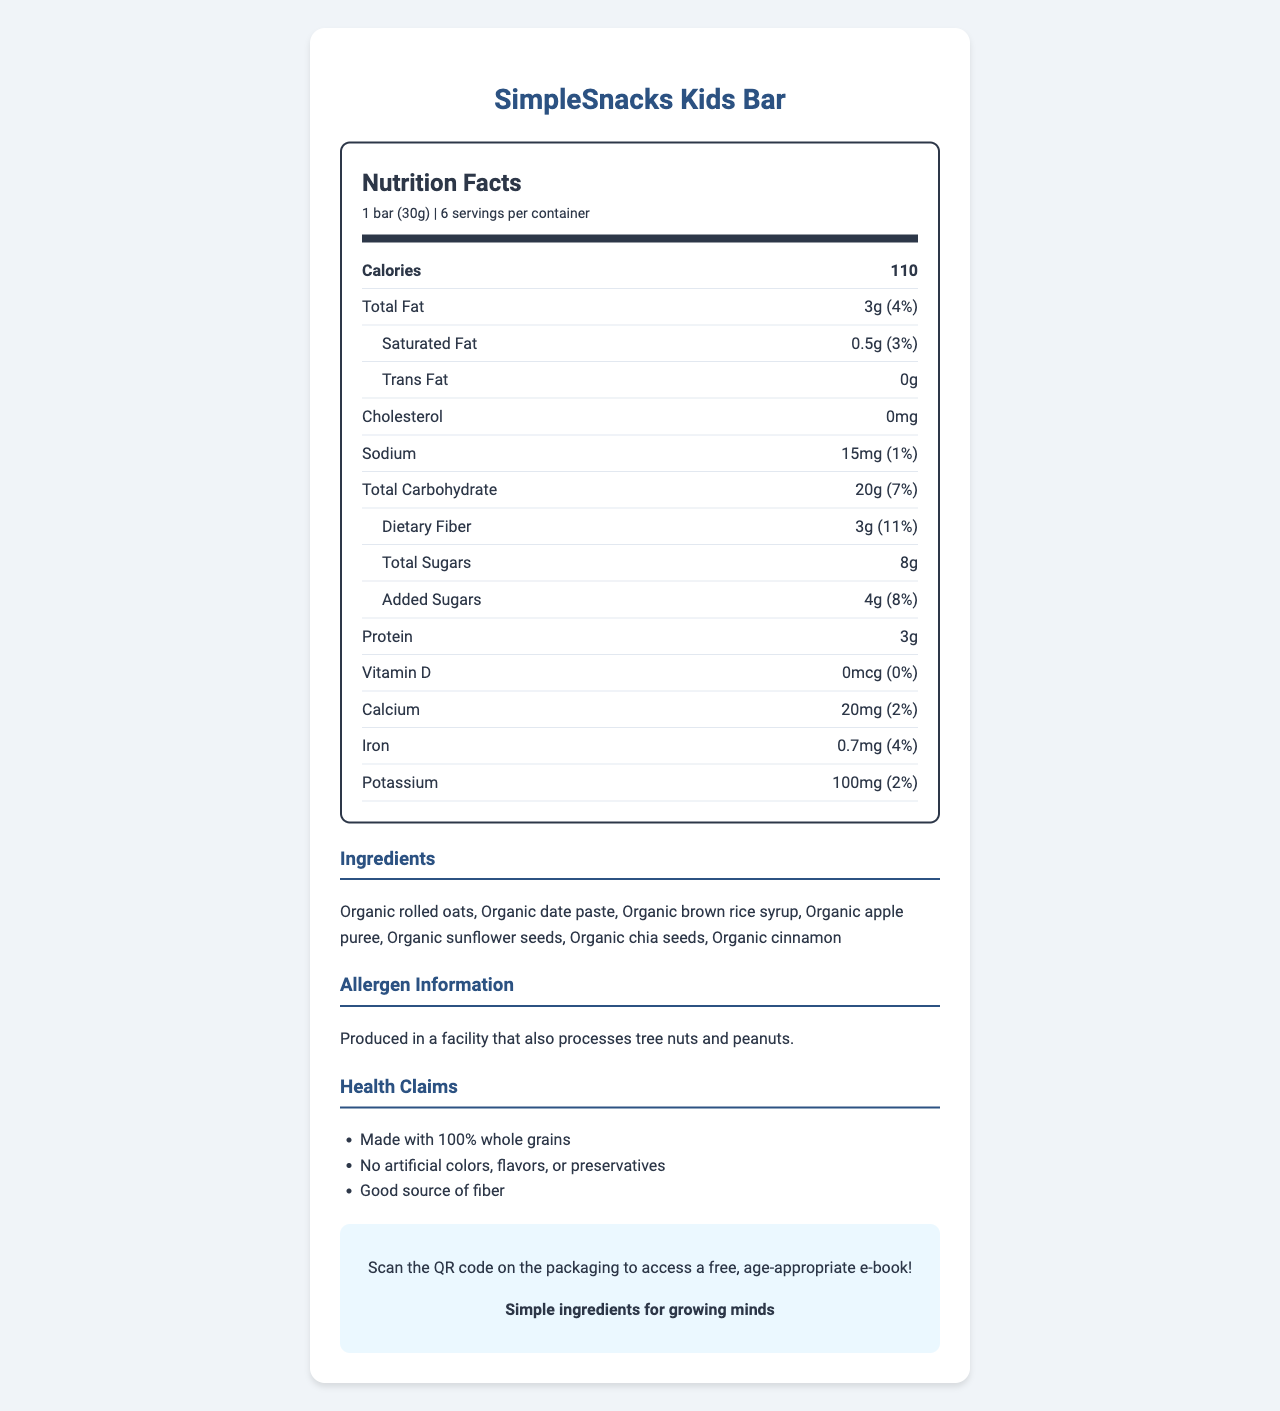what is the serving size of the SimpleSnacks Kids Bar? The serving size information is clearly indicated at the top of the Nutrition Facts section.
Answer: 1 bar (30g) how many calories are there per serving? The calories per serving are listed directly under the serving size and servings per container.
Answer: 110 calories what is the total fat content of a single bar? The total fat content is mentioned in the Nutrition Facts section under the calories.
Answer: 3g how much dietary fiber does a single bar contain? Dietary fiber content is listed in the Nutrition Facts section under the total carbohydrate information.
Answer: 3g what ingredients are used in the SimpleSnacks Kids Bar? The ingredients are listed in the Ingredients section of the document.
Answer: Organic rolled oats, Organic date paste, Organic brown rice syrup, Organic apple puree, Organic sunflower seeds, Organic chia seeds, Organic cinnamon how much protein is there per serving? The protein content is listed in the Nutrition Facts section under the added sugars.
Answer: 3g why might parents find this snack bar a good choice for children? The Health Claims section lists the benefits that might appeal to parents.
Answer: Made with 100% whole grains, No artificial colors, flavors, or preservatives, Good source of fiber what percentage of your daily value of calcium is provided by a single bar? The calcium daily value percentage is mentioned in the Nutrition Facts section near the bottom.
Answer: 2% what is the sodium content per serving? A. 5mg B. 10mg C. 15mg D. 20mg The sodium content is listed in the Nutrition Facts section.
Answer: C. 15mg which of the following is true about the SimpleSnacks Kids Bar? I. Contains artificial preservatives II. Made with 100% whole grains III. Contains tree nuts The Health Claims section states it is made with 100% whole grains, while the Allergen Information section mentions it is produced in a facility that processes tree nuts, but the bar itself does not contain them.
Answer: II is this product suitable for kids who are allergic to peanuts? The Allergen Information section notes that it is produced in a facility that also processes tree nuts and peanuts.
Answer: No how many servings are there in one container of SimpleSnacks Kids Bar? The serving information is listed at the top, indicating there are 6 servings per container.
Answer: 6 what is the main idea of this document? The document provides detailed nutrition facts, lists ingredients, health claims, allergen information, and additional benefits focused on the SimpleSnacks Kids Bar.
Answer: Nutrition information and benefits of SimpleSnacks Kids Bar what is the sustainability claim made about this product? The Additional Information section mentions that the packaging is made from 100% recycled materials.
Answer: Packaging made from 100% recycled materials can this document tell you the price of the SimpleSnacks Kids Bar? The document does not provide pricing information.
Answer: Not enough information 